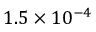Convert formula to latex. <formula><loc_0><loc_0><loc_500><loc_500>1 . 5 \times 1 0 ^ { - 4 }</formula> 